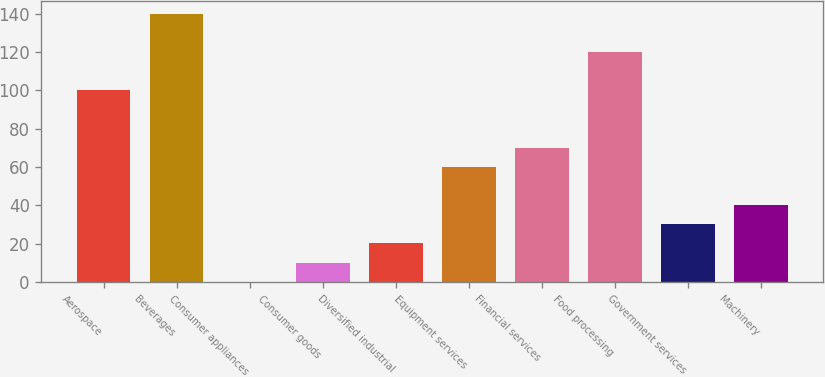Convert chart. <chart><loc_0><loc_0><loc_500><loc_500><bar_chart><fcel>Aerospace<fcel>Beverages<fcel>Consumer appliances<fcel>Consumer goods<fcel>Diversified industrial<fcel>Equipment services<fcel>Financial services<fcel>Food processing<fcel>Government services<fcel>Machinery<nl><fcel>100<fcel>139.96<fcel>0.1<fcel>10.09<fcel>20.08<fcel>60.04<fcel>70.03<fcel>119.98<fcel>30.07<fcel>40.06<nl></chart> 